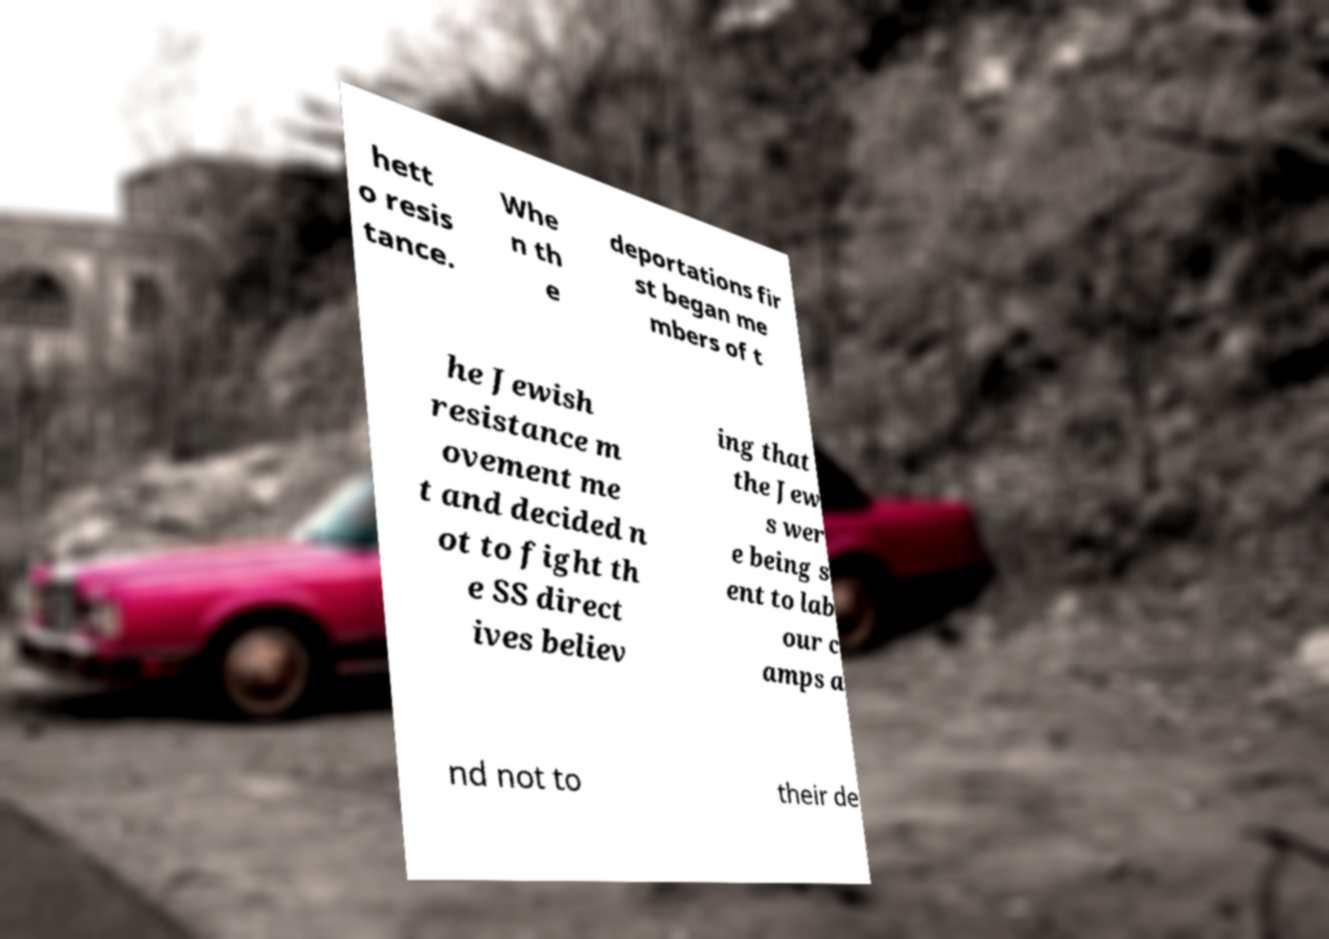Please identify and transcribe the text found in this image. hett o resis tance. Whe n th e deportations fir st began me mbers of t he Jewish resistance m ovement me t and decided n ot to fight th e SS direct ives believ ing that the Jew s wer e being s ent to lab our c amps a nd not to their de 